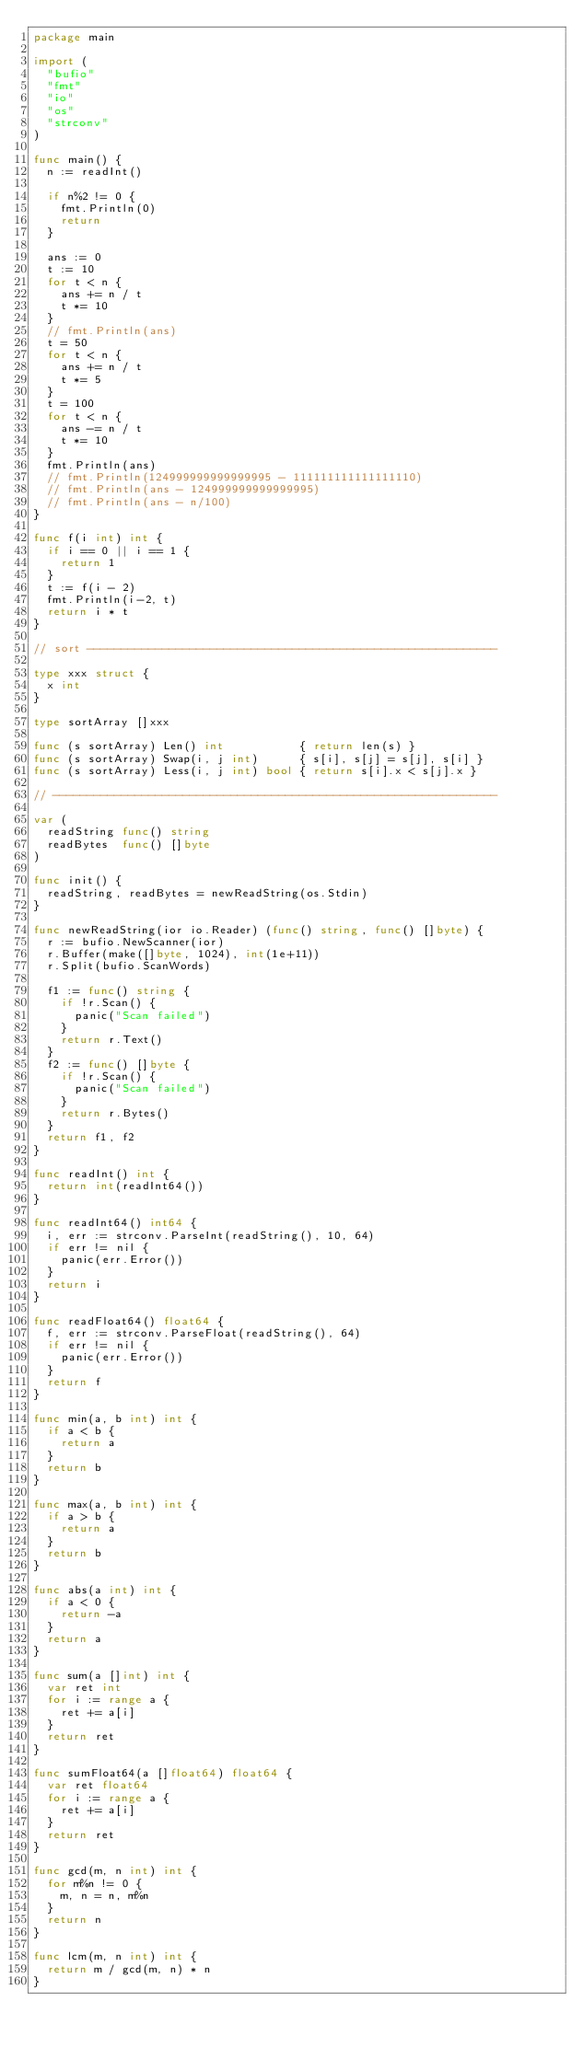Convert code to text. <code><loc_0><loc_0><loc_500><loc_500><_Go_>package main

import (
	"bufio"
	"fmt"
	"io"
	"os"
	"strconv"
)

func main() {
	n := readInt()

	if n%2 != 0 {
		fmt.Println(0)
		return
	}

	ans := 0
	t := 10
	for t < n {
		ans += n / t
		t *= 10
	}
	// fmt.Println(ans)
	t = 50
	for t < n {
		ans += n / t
		t *= 5
	}
	t = 100
	for t < n {
		ans -= n / t
		t *= 10
	}
	fmt.Println(ans)
	// fmt.Println(124999999999999995 - 111111111111111110)
	// fmt.Println(ans - 124999999999999995)
	// fmt.Println(ans - n/100)
}

func f(i int) int {
	if i == 0 || i == 1 {
		return 1
	}
	t := f(i - 2)
	fmt.Println(i-2, t)
	return i * t
}

// sort ------------------------------------------------------------

type xxx struct {
	x int
}

type sortArray []xxx

func (s sortArray) Len() int           { return len(s) }
func (s sortArray) Swap(i, j int)      { s[i], s[j] = s[j], s[i] }
func (s sortArray) Less(i, j int) bool { return s[i].x < s[j].x }

// -----------------------------------------------------------------

var (
	readString func() string
	readBytes  func() []byte
)

func init() {
	readString, readBytes = newReadString(os.Stdin)
}

func newReadString(ior io.Reader) (func() string, func() []byte) {
	r := bufio.NewScanner(ior)
	r.Buffer(make([]byte, 1024), int(1e+11))
	r.Split(bufio.ScanWords)

	f1 := func() string {
		if !r.Scan() {
			panic("Scan failed")
		}
		return r.Text()
	}
	f2 := func() []byte {
		if !r.Scan() {
			panic("Scan failed")
		}
		return r.Bytes()
	}
	return f1, f2
}

func readInt() int {
	return int(readInt64())
}

func readInt64() int64 {
	i, err := strconv.ParseInt(readString(), 10, 64)
	if err != nil {
		panic(err.Error())
	}
	return i
}

func readFloat64() float64 {
	f, err := strconv.ParseFloat(readString(), 64)
	if err != nil {
		panic(err.Error())
	}
	return f
}

func min(a, b int) int {
	if a < b {
		return a
	}
	return b
}

func max(a, b int) int {
	if a > b {
		return a
	}
	return b
}

func abs(a int) int {
	if a < 0 {
		return -a
	}
	return a
}

func sum(a []int) int {
	var ret int
	for i := range a {
		ret += a[i]
	}
	return ret
}

func sumFloat64(a []float64) float64 {
	var ret float64
	for i := range a {
		ret += a[i]
	}
	return ret
}

func gcd(m, n int) int {
	for m%n != 0 {
		m, n = n, m%n
	}
	return n
}

func lcm(m, n int) int {
	return m / gcd(m, n) * n
}
</code> 